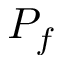Convert formula to latex. <formula><loc_0><loc_0><loc_500><loc_500>P _ { f }</formula> 